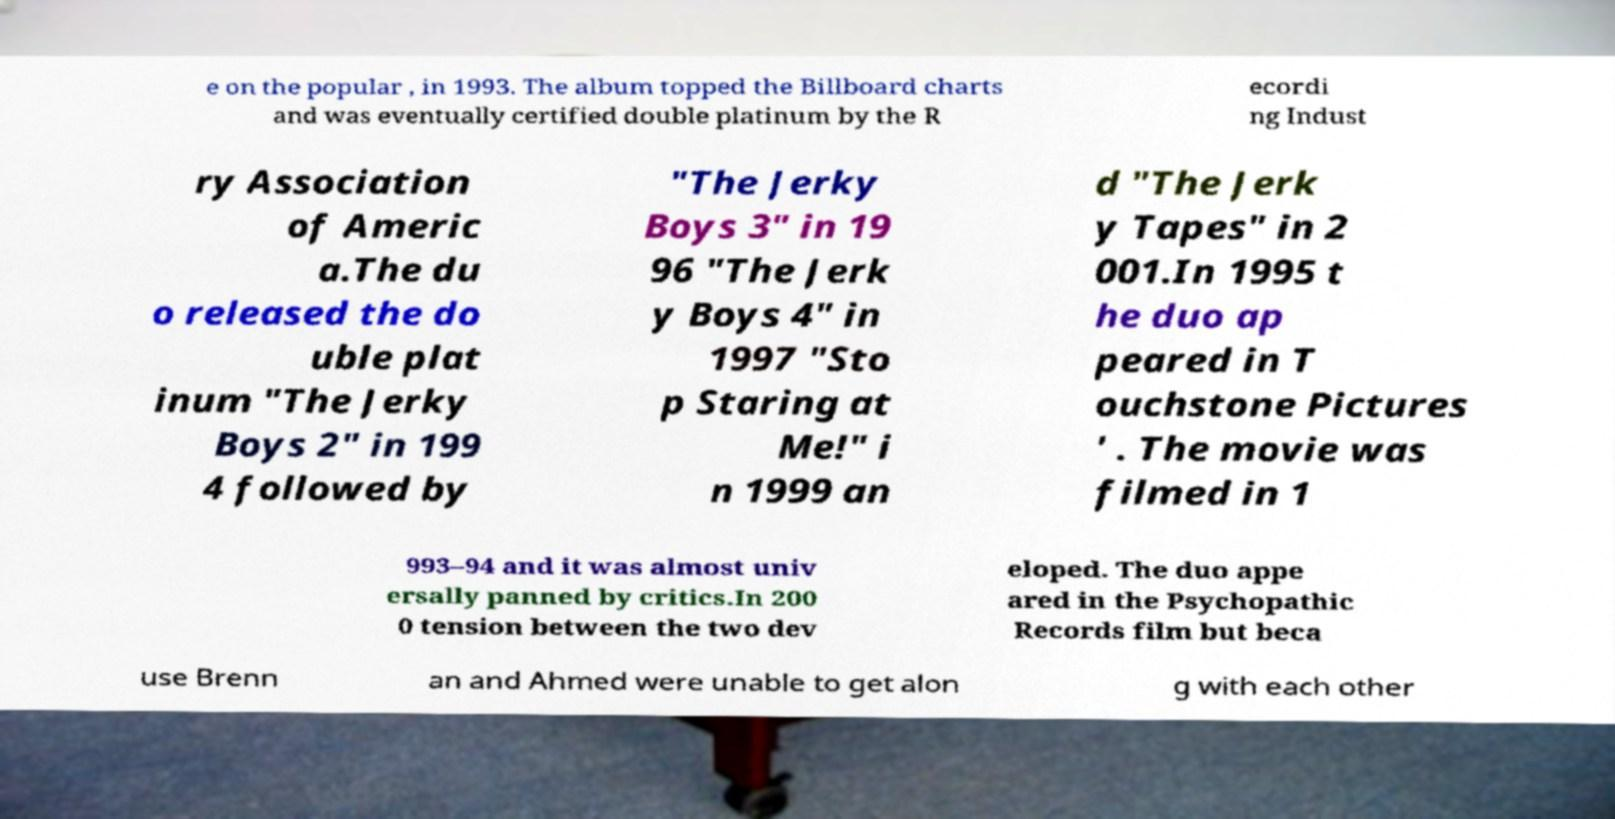There's text embedded in this image that I need extracted. Can you transcribe it verbatim? e on the popular , in 1993. The album topped the Billboard charts and was eventually certified double platinum by the R ecordi ng Indust ry Association of Americ a.The du o released the do uble plat inum "The Jerky Boys 2" in 199 4 followed by "The Jerky Boys 3" in 19 96 "The Jerk y Boys 4" in 1997 "Sto p Staring at Me!" i n 1999 an d "The Jerk y Tapes" in 2 001.In 1995 t he duo ap peared in T ouchstone Pictures ' . The movie was filmed in 1 993–94 and it was almost univ ersally panned by critics.In 200 0 tension between the two dev eloped. The duo appe ared in the Psychopathic Records film but beca use Brenn an and Ahmed were unable to get alon g with each other 